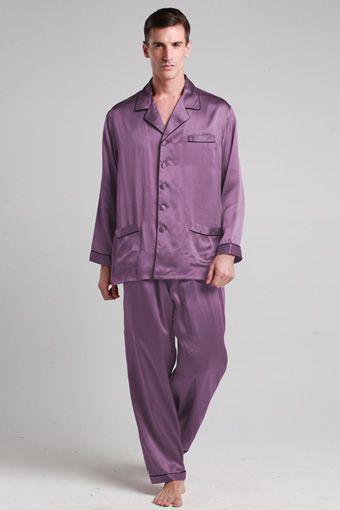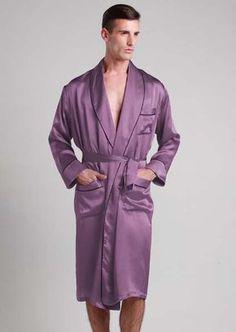The first image is the image on the left, the second image is the image on the right. Examine the images to the left and right. Is the description "In one image, a man wearing solid color silky pajamas with cuffs on both shirt and pants is standing with one foot forward." accurate? Answer yes or no. Yes. The first image is the image on the left, the second image is the image on the right. For the images displayed, is the sentence "There are no pieces of furniture in the background of these images." factually correct? Answer yes or no. Yes. 